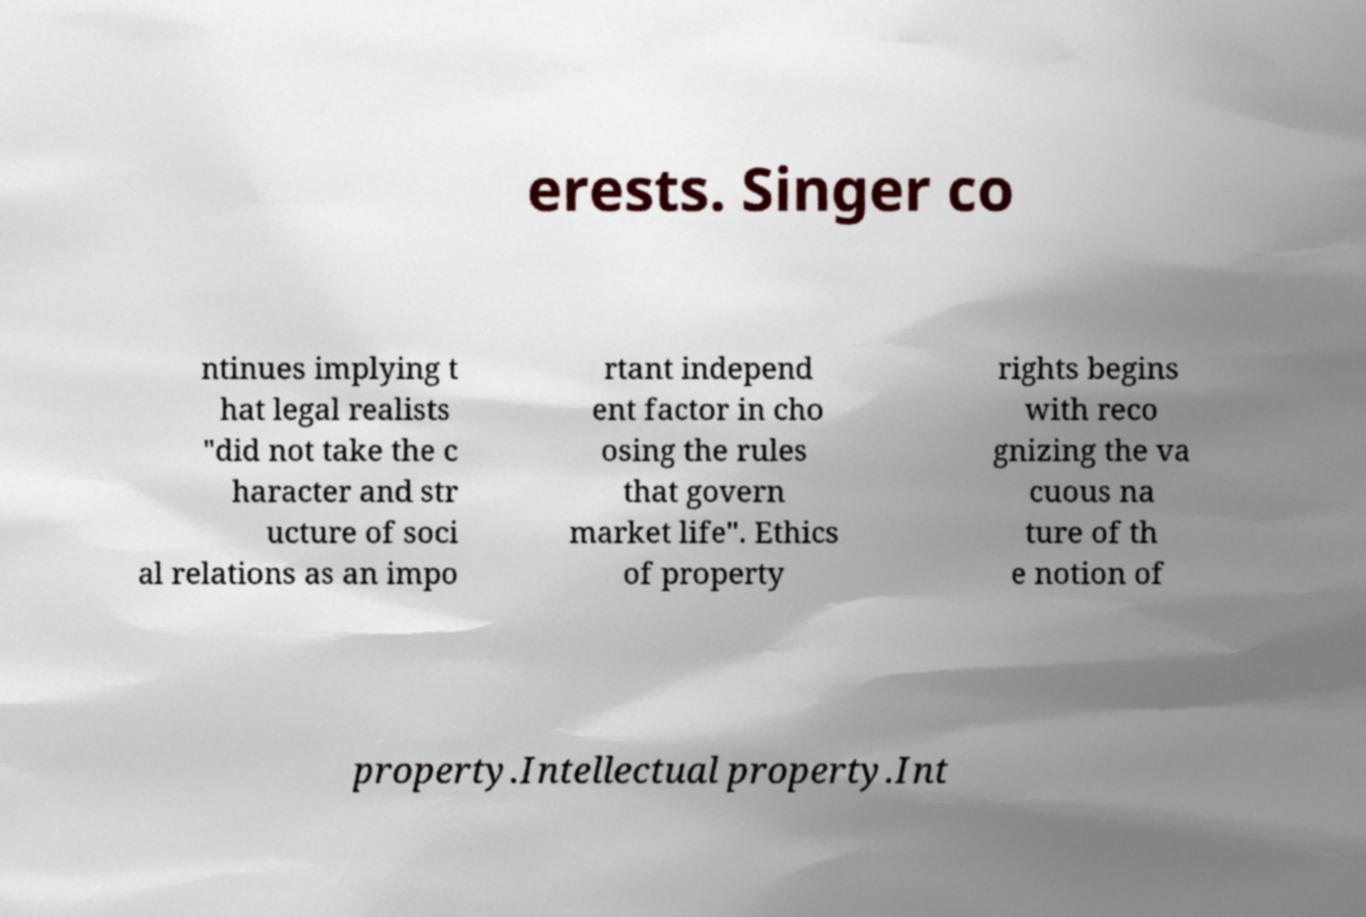Can you read and provide the text displayed in the image?This photo seems to have some interesting text. Can you extract and type it out for me? erests. Singer co ntinues implying t hat legal realists "did not take the c haracter and str ucture of soci al relations as an impo rtant independ ent factor in cho osing the rules that govern market life". Ethics of property rights begins with reco gnizing the va cuous na ture of th e notion of property.Intellectual property.Int 